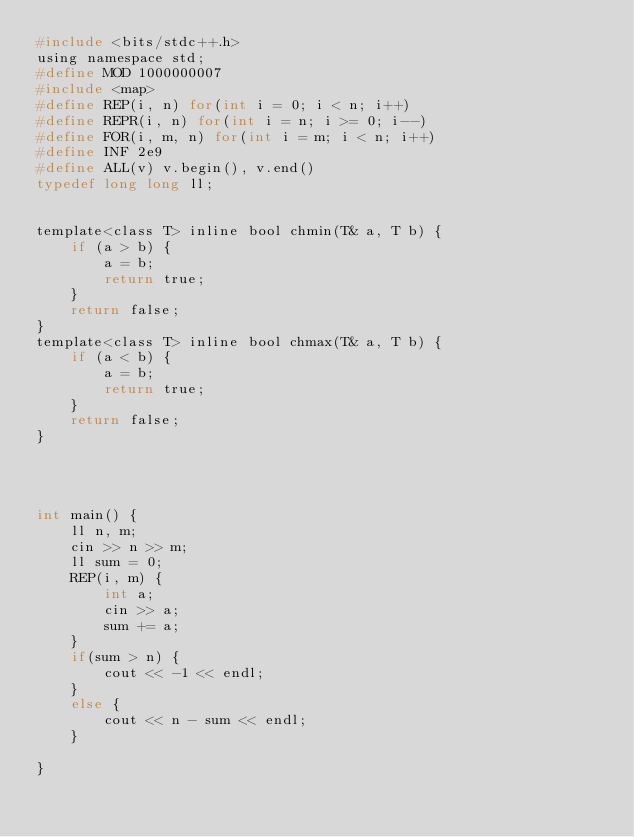Convert code to text. <code><loc_0><loc_0><loc_500><loc_500><_C_>#include <bits/stdc++.h>
using namespace std;
#define MOD 1000000007
#include <map>
#define REP(i, n) for(int i = 0; i < n; i++)
#define REPR(i, n) for(int i = n; i >= 0; i--)
#define FOR(i, m, n) for(int i = m; i < n; i++)
#define INF 2e9
#define ALL(v) v.begin(), v.end()
typedef long long ll;


template<class T> inline bool chmin(T& a, T b) {
    if (a > b) {
        a = b;
        return true;
    }
    return false;
}
template<class T> inline bool chmax(T& a, T b) {
    if (a < b) {
        a = b;
        return true;
    }
    return false;
}




int main() {
    ll n, m;
    cin >> n >> m;
    ll sum = 0;
    REP(i, m) {
        int a;
        cin >> a;
        sum += a;
    }
    if(sum > n) {
        cout << -1 << endl;
    }
    else {
        cout << n - sum << endl;
    }

}
</code> 